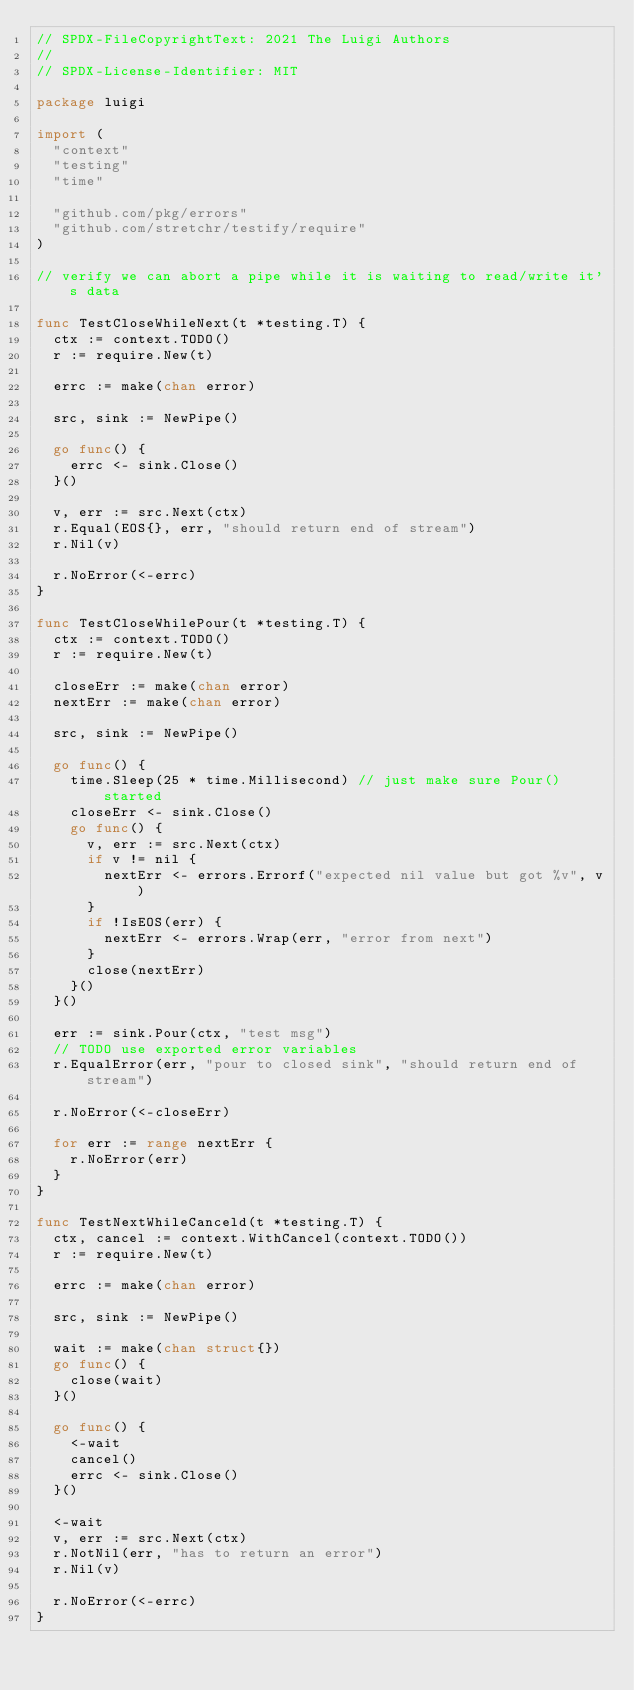Convert code to text. <code><loc_0><loc_0><loc_500><loc_500><_Go_>// SPDX-FileCopyrightText: 2021 The Luigi Authors
//
// SPDX-License-Identifier: MIT

package luigi

import (
	"context"
	"testing"
	"time"

	"github.com/pkg/errors"
	"github.com/stretchr/testify/require"
)

// verify we can abort a pipe while it is waiting to read/write it's data

func TestCloseWhileNext(t *testing.T) {
	ctx := context.TODO()
	r := require.New(t)

	errc := make(chan error)

	src, sink := NewPipe()

	go func() {
		errc <- sink.Close()
	}()

	v, err := src.Next(ctx)
	r.Equal(EOS{}, err, "should return end of stream")
	r.Nil(v)

	r.NoError(<-errc)
}

func TestCloseWhilePour(t *testing.T) {
	ctx := context.TODO()
	r := require.New(t)

	closeErr := make(chan error)
	nextErr := make(chan error)

	src, sink := NewPipe()

	go func() {
		time.Sleep(25 * time.Millisecond) // just make sure Pour() started
		closeErr <- sink.Close()
		go func() {
			v, err := src.Next(ctx)
			if v != nil {
				nextErr <- errors.Errorf("expected nil value but got %v", v)
			}
			if !IsEOS(err) {
				nextErr <- errors.Wrap(err, "error from next")
			}
			close(nextErr)
		}()
	}()

	err := sink.Pour(ctx, "test msg")
	// TODO use exported error variables
	r.EqualError(err, "pour to closed sink", "should return end of stream")

	r.NoError(<-closeErr)

	for err := range nextErr {
		r.NoError(err)
	}
}

func TestNextWhileCanceld(t *testing.T) {
	ctx, cancel := context.WithCancel(context.TODO())
	r := require.New(t)

	errc := make(chan error)

	src, sink := NewPipe()

	wait := make(chan struct{})
	go func() {
		close(wait)
	}()

	go func() {
		<-wait
		cancel()
		errc <- sink.Close()
	}()

	<-wait
	v, err := src.Next(ctx)
	r.NotNil(err, "has to return an error")
	r.Nil(v)

	r.NoError(<-errc)
}
</code> 